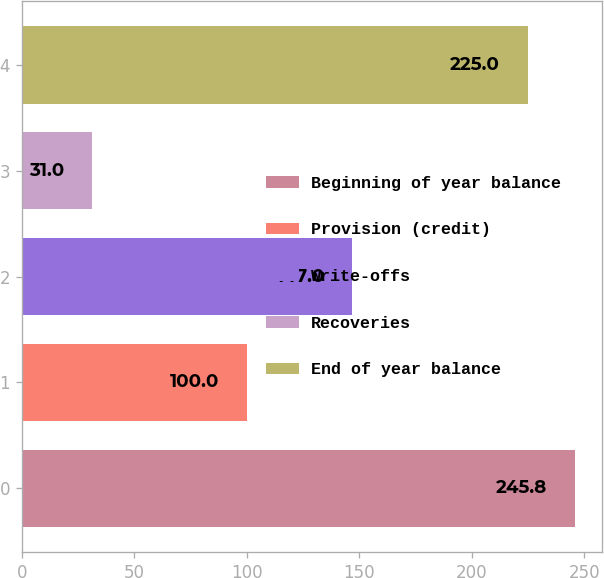Convert chart to OTSL. <chart><loc_0><loc_0><loc_500><loc_500><bar_chart><fcel>Beginning of year balance<fcel>Provision (credit)<fcel>Write-offs<fcel>Recoveries<fcel>End of year balance<nl><fcel>245.8<fcel>100<fcel>147<fcel>31<fcel>225<nl></chart> 